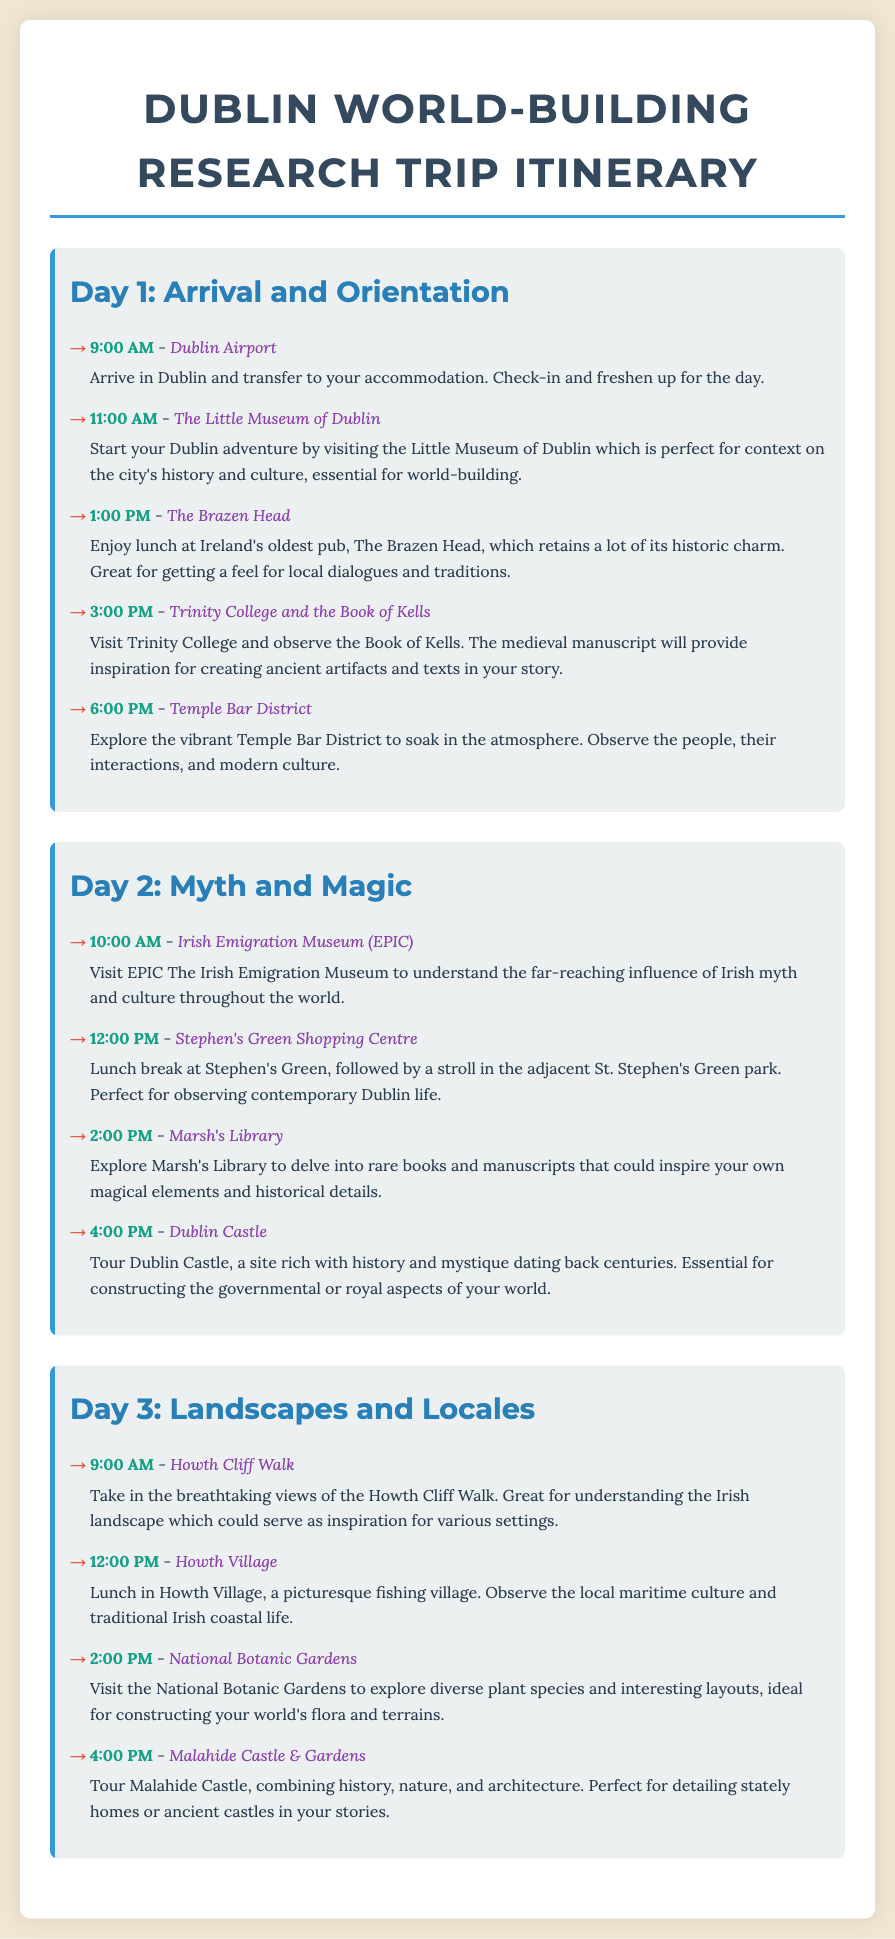What time does Day 1 start? The itinerary for Day 1 starts with an activity at 9:00 AM at Dublin Airport.
Answer: 9:00 AM What is the last activity listed for Day 2? The last activity listed for Day 2 is a tour of Dublin Castle at 4:00 PM.
Answer: Dublin Castle How many days does the research trip cover? The document outlines a research trip itinerary that spans across three days.
Answer: Three days Which museum focuses on Irish emigration? The Irish Emigration Museum (EPIC) is highlighted for its focus on Irish emigration.
Answer: EPIC What is the location for lunch on Day 3? The itinerary specifies having lunch in Howth Village on Day 3.
Answer: Howth Village Which location is recommended for exploring plant species? The National Botanic Gardens is mentioned as the site for exploring diverse plant species.
Answer: National Botanic Gardens What activity takes place at Trinity College? At Trinity College, the activity involves observing the Book of Kells.
Answer: Observing the Book of Kells What is the first activity of Day 1? The first activity of Day 1 involves arriving at Dublin Airport and transferring to accommodation.
Answer: Arriving at Dublin Airport 